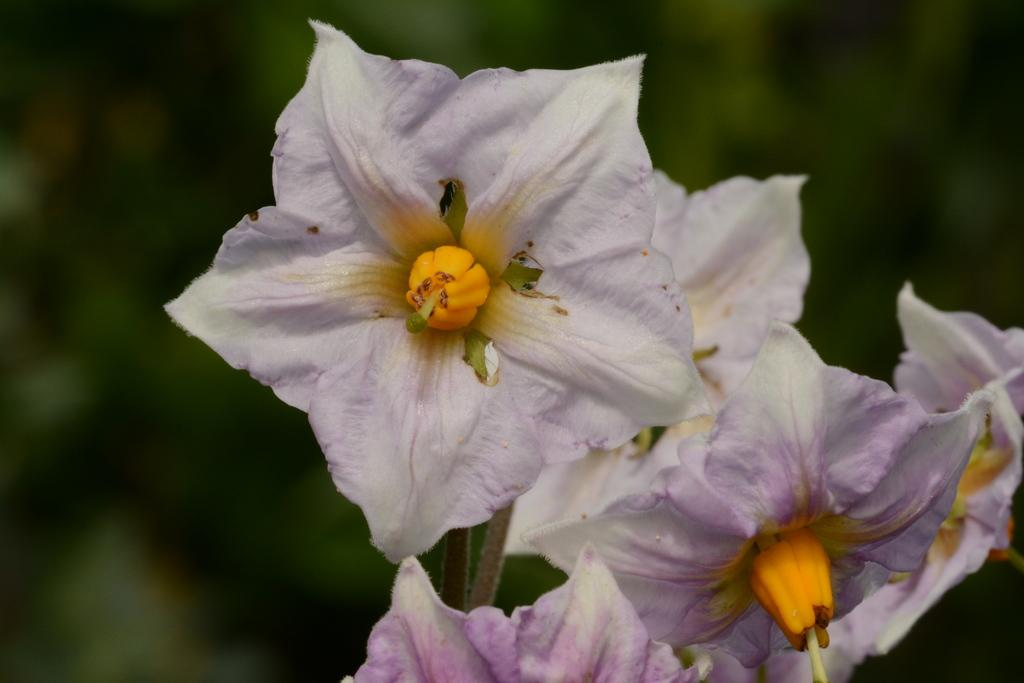What type of living organisms can be seen in the image? There are flowers in the image. What color are the flowers in the image? The flowers are white in color. Can you hear the alarm going off in the image? There is no alarm present in the image, so it cannot be heard. 